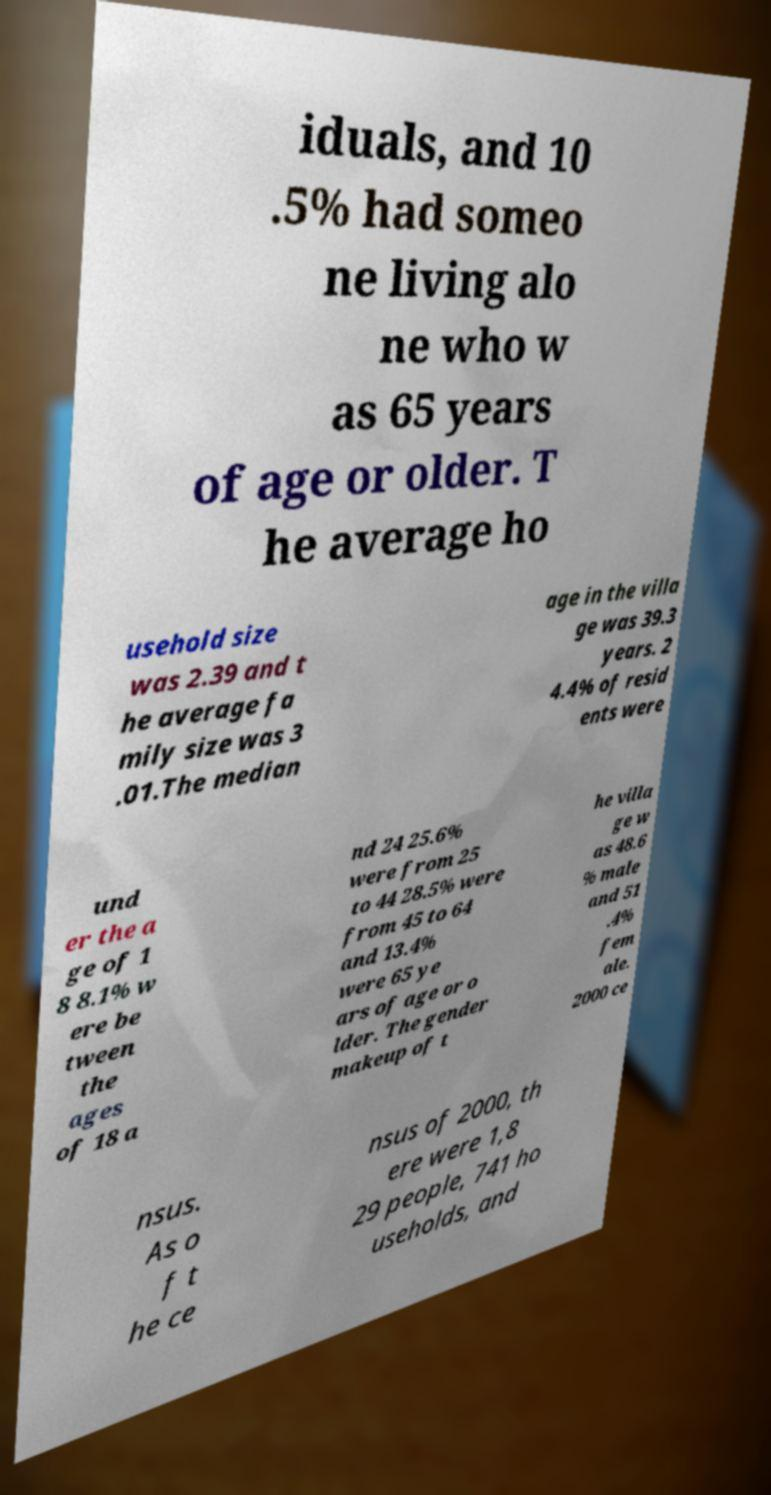Could you assist in decoding the text presented in this image and type it out clearly? iduals, and 10 .5% had someo ne living alo ne who w as 65 years of age or older. T he average ho usehold size was 2.39 and t he average fa mily size was 3 .01.The median age in the villa ge was 39.3 years. 2 4.4% of resid ents were und er the a ge of 1 8 8.1% w ere be tween the ages of 18 a nd 24 25.6% were from 25 to 44 28.5% were from 45 to 64 and 13.4% were 65 ye ars of age or o lder. The gender makeup of t he villa ge w as 48.6 % male and 51 .4% fem ale. 2000 ce nsus. As o f t he ce nsus of 2000, th ere were 1,8 29 people, 741 ho useholds, and 